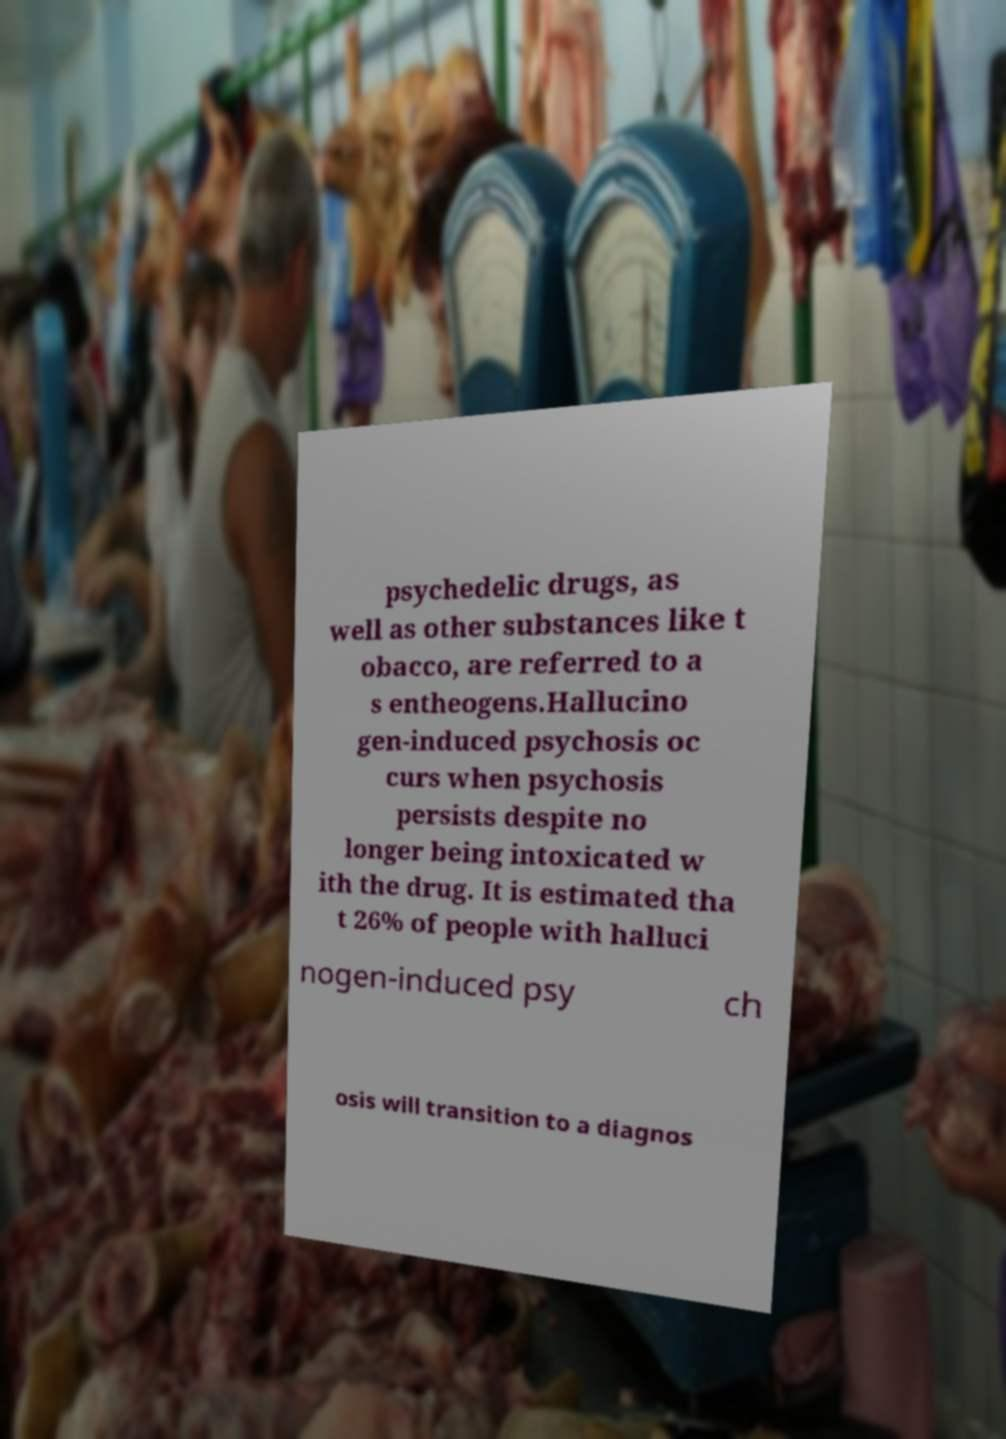Could you extract and type out the text from this image? psychedelic drugs, as well as other substances like t obacco, are referred to a s entheogens.Hallucino gen-induced psychosis oc curs when psychosis persists despite no longer being intoxicated w ith the drug. It is estimated tha t 26% of people with halluci nogen-induced psy ch osis will transition to a diagnos 